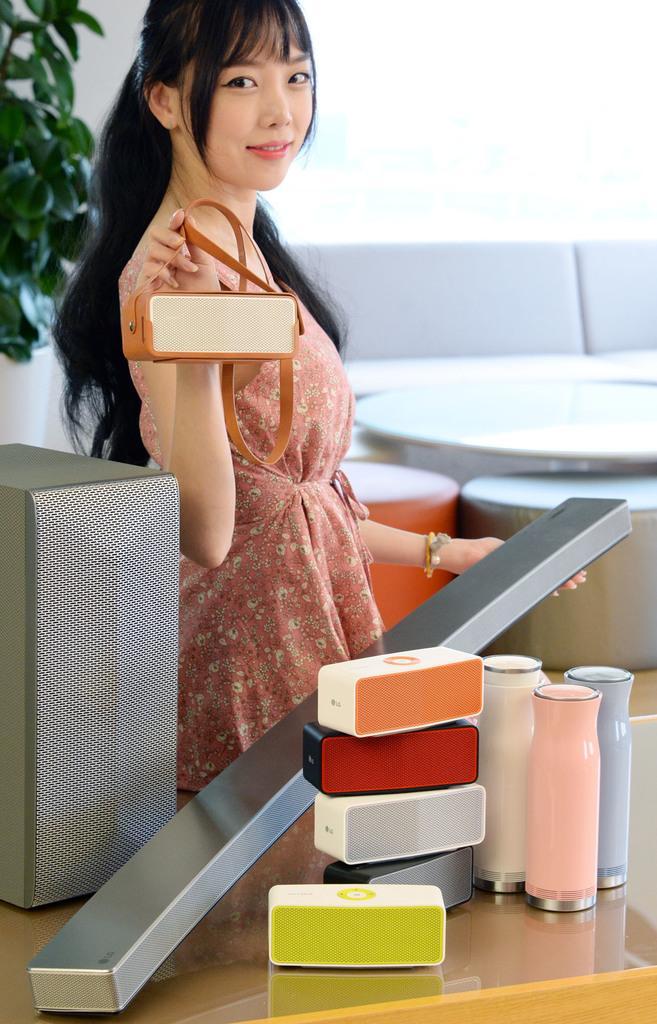Describe this image in one or two sentences. In this image I can see a person is standing and holding something. I can see few bottles, few colorful boxes and few objects on the table. Back I can see a couch, table and plant. Background is in white color. 